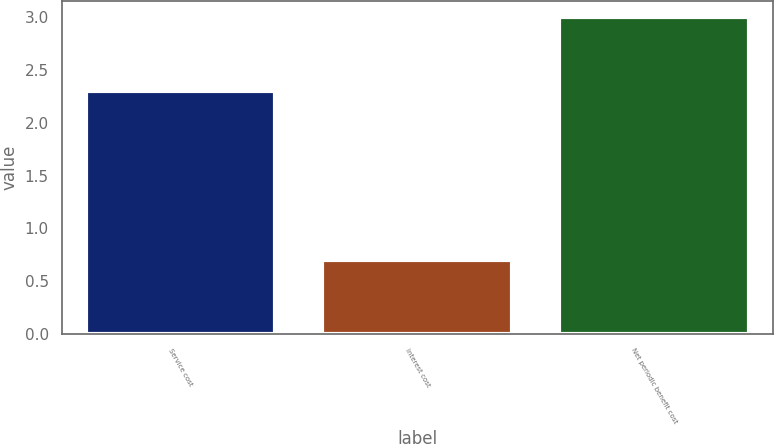Convert chart to OTSL. <chart><loc_0><loc_0><loc_500><loc_500><bar_chart><fcel>Service cost<fcel>Interest cost<fcel>Net periodic benefit cost<nl><fcel>2.3<fcel>0.7<fcel>3<nl></chart> 